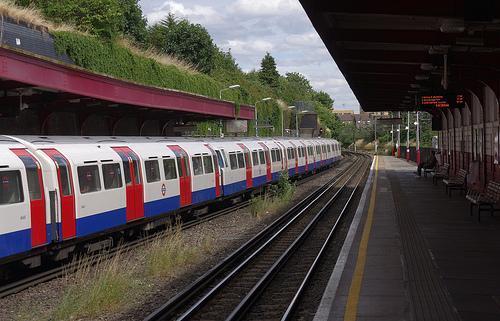How many sets of tracks are there?
Give a very brief answer. 2. How many people are sitting on the benches?
Give a very brief answer. 1. 